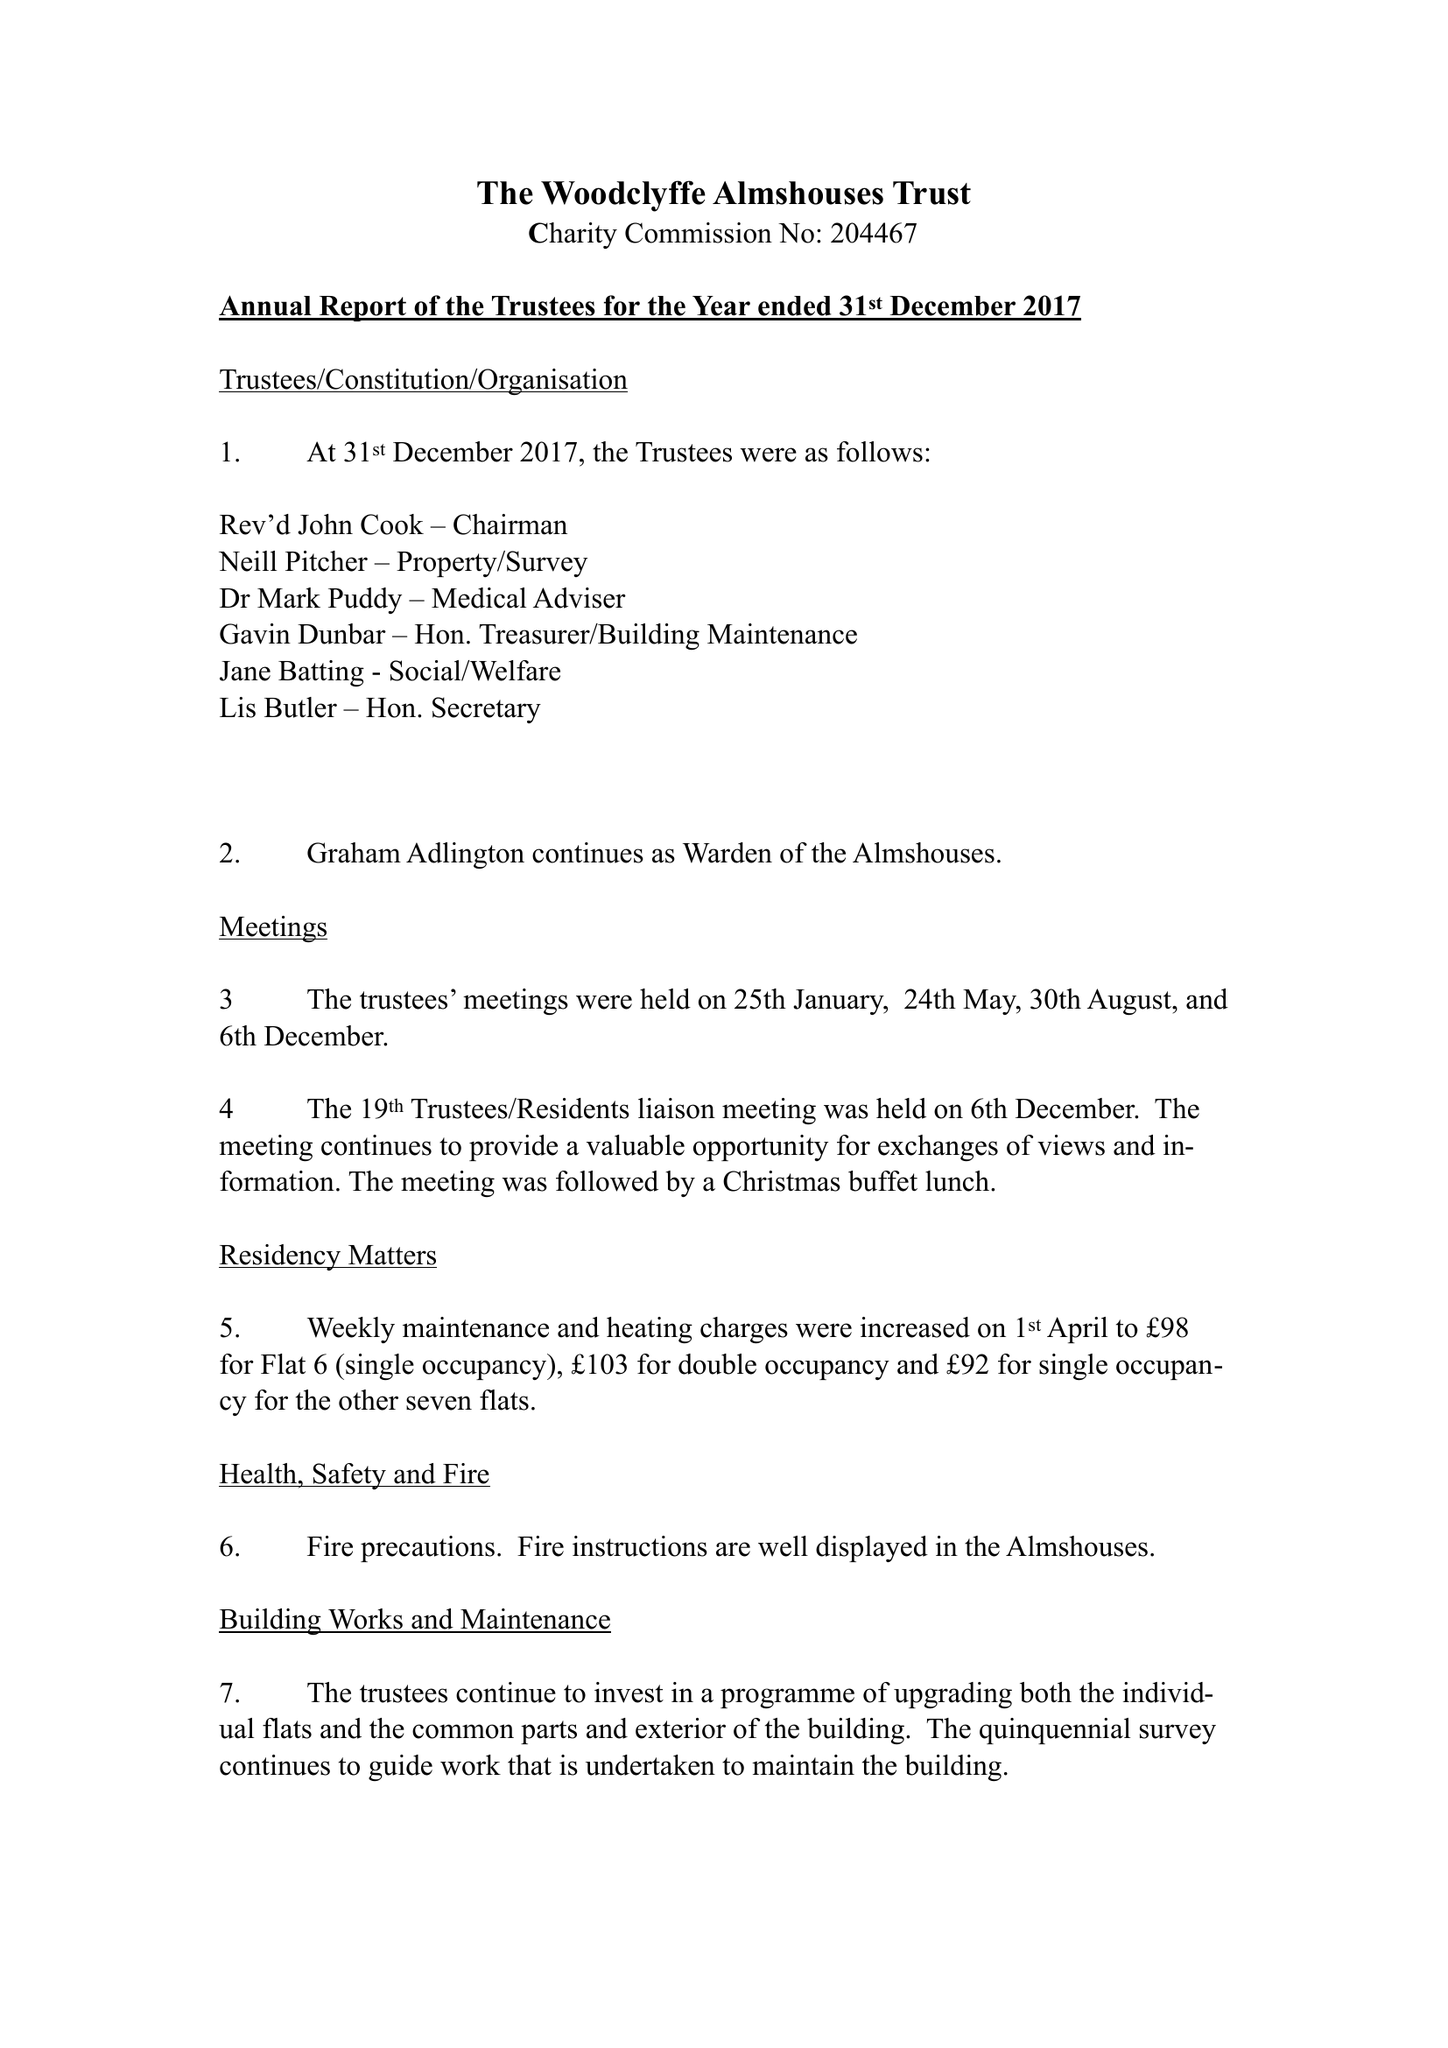What is the value for the address__street_line?
Answer the question using a single word or phrase. 4B HIGH STREET 